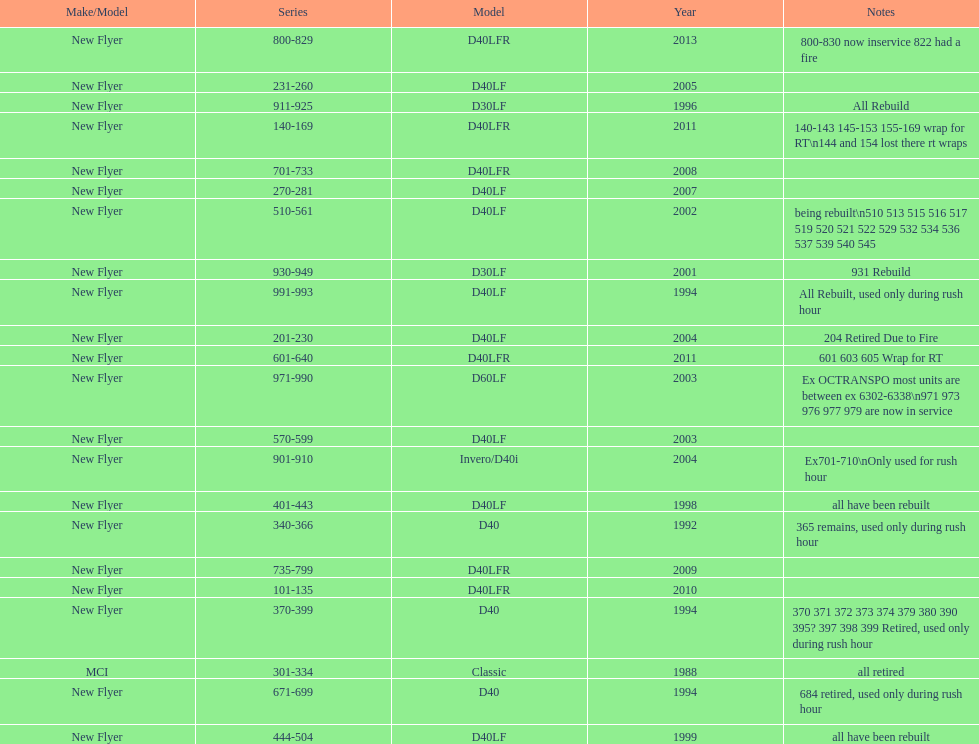Which buses are the newest in the current fleet? 800-829. 